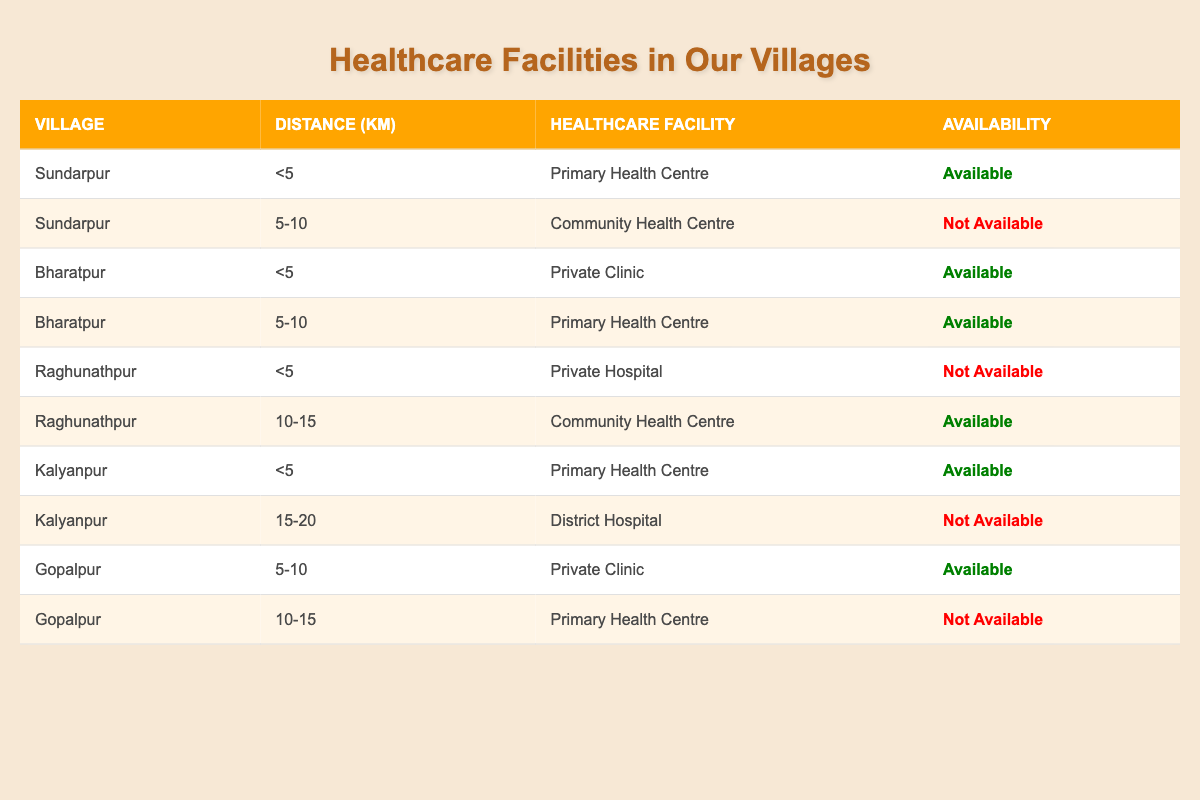What is the availability status of healthcare facilities in Sundarpur? In Sundarpur, there are two entries in the table: one for a Primary Health Centre with a distance of less than 5 km, which is available, and another for a Community Health Centre at a distance of 5-10 km, which is not available.
Answer: Available, Not Available How many healthcare facilities are available in Bharatpur? Bharatpur has two entries in the table: a Private Clinic available at less than 5 km and a Primary Health Centre at a distance of 5-10 km, which is also available. Therefore, there are two available healthcare facilities.
Answer: 2 Are there any healthcare facilities available in Kalyanpur? In Kalyanpur, there is one entry for a Primary Health Centre available at less than 5 km, and another entry for a District Hospital at a distance of 15-20 km, which is not available. Hence, there is at least one available healthcare facility.
Answer: Yes What is the total number of healthcare facilities listed in Gopalpur? Gopalpur has two entries: one for a Private Clinic (available) within 5-10 km and another for a Primary Health Centre (not available) at a distance of 10-15 km. So, there are two healthcare facilities in Gopalpur.
Answer: 2 Which village has the closest healthcare facility and what type is it? The closest healthcare facility, which is less than 5 km away, is in Sundarpur, specifically a Primary Health Centre available.
Answer: Sundarpur, Primary Health Centre What is the average distance from the healthcare facilities in Raghunathpur? In Raghunathpur, there are two entries: one at less than 5 km and another at 10-15 km. To find the average, convert the ranges: (5 + 10 + 15) / 3 = 10 km. Hence, the average distance of healthcare facilities in Raghunathpur is 10 km.
Answer: 10 km Is there a healthcare facility available in Gopalpur at a distance of 10-15 km? The entry for Gopalpur at a distance of 10-15 km is a Primary Health Centre, and it shows 'Not Available,' indicating that there are no available healthcare facilities in that range.
Answer: No Which village has the highest availability of healthcare facilities based on the table? By analyzing the table, Bharatpur has two healthcare facilities available, while Sundarpur and Kalyanpur each have one. Since Bharatpur has the most available, it has the highest availability.
Answer: Bharatpur 